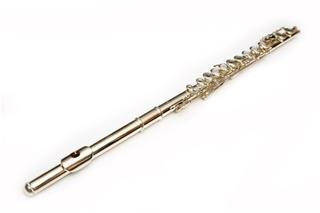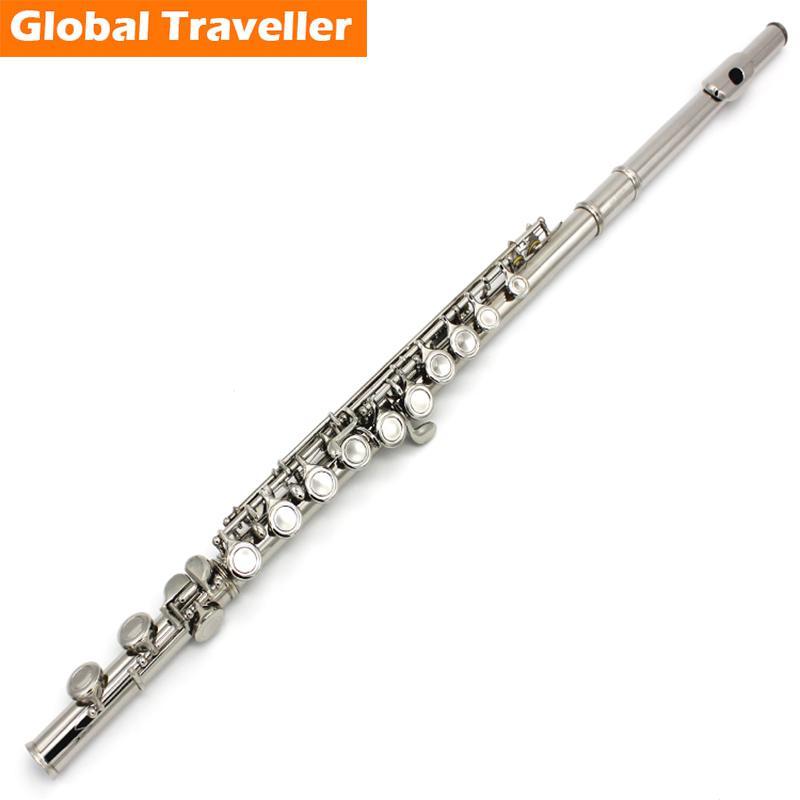The first image is the image on the left, the second image is the image on the right. Assess this claim about the two images: "The flute-like instruments on the left and right are silver colored and displayed at opposite angles so they form a V shape.". Correct or not? Answer yes or no. No. The first image is the image on the left, the second image is the image on the right. Considering the images on both sides, is "The left and right image contains the same number of silver flutes the are opposite facing." valid? Answer yes or no. No. 